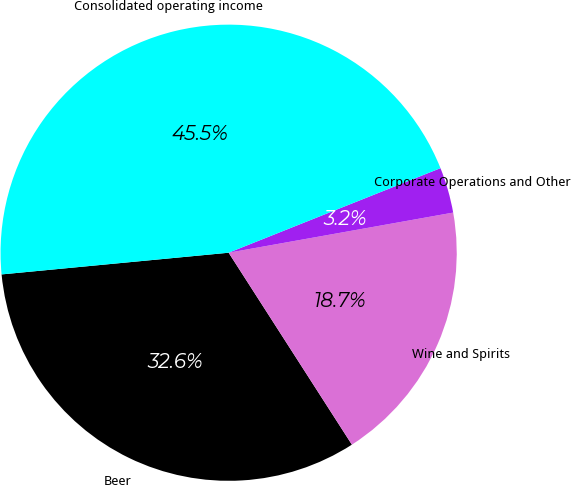Convert chart to OTSL. <chart><loc_0><loc_0><loc_500><loc_500><pie_chart><fcel>Beer<fcel>Wine and Spirits<fcel>Corporate Operations and Other<fcel>Consolidated operating income<nl><fcel>32.57%<fcel>18.73%<fcel>3.23%<fcel>45.47%<nl></chart> 